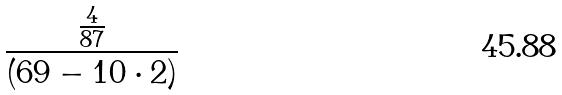Convert formula to latex. <formula><loc_0><loc_0><loc_500><loc_500>\frac { \frac { 4 } { 8 7 } } { ( 6 9 - 1 0 \cdot 2 ) }</formula> 